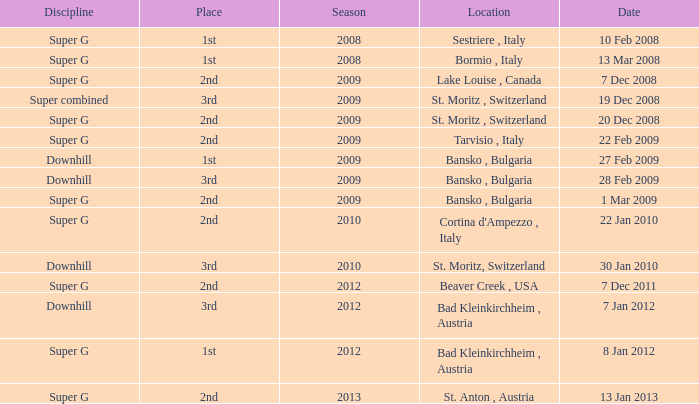What is the date of Super G in the 2010 season? 22 Jan 2010. 